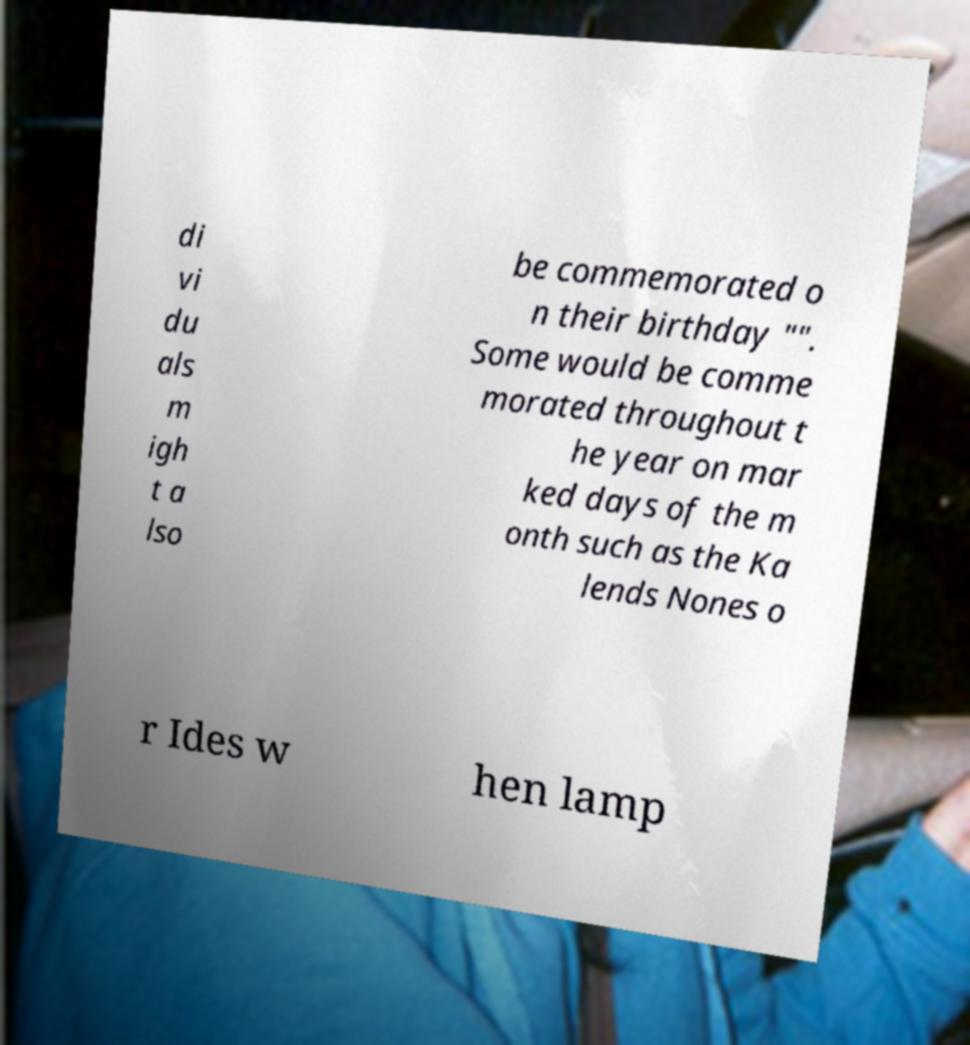I need the written content from this picture converted into text. Can you do that? di vi du als m igh t a lso be commemorated o n their birthday "". Some would be comme morated throughout t he year on mar ked days of the m onth such as the Ka lends Nones o r Ides w hen lamp 